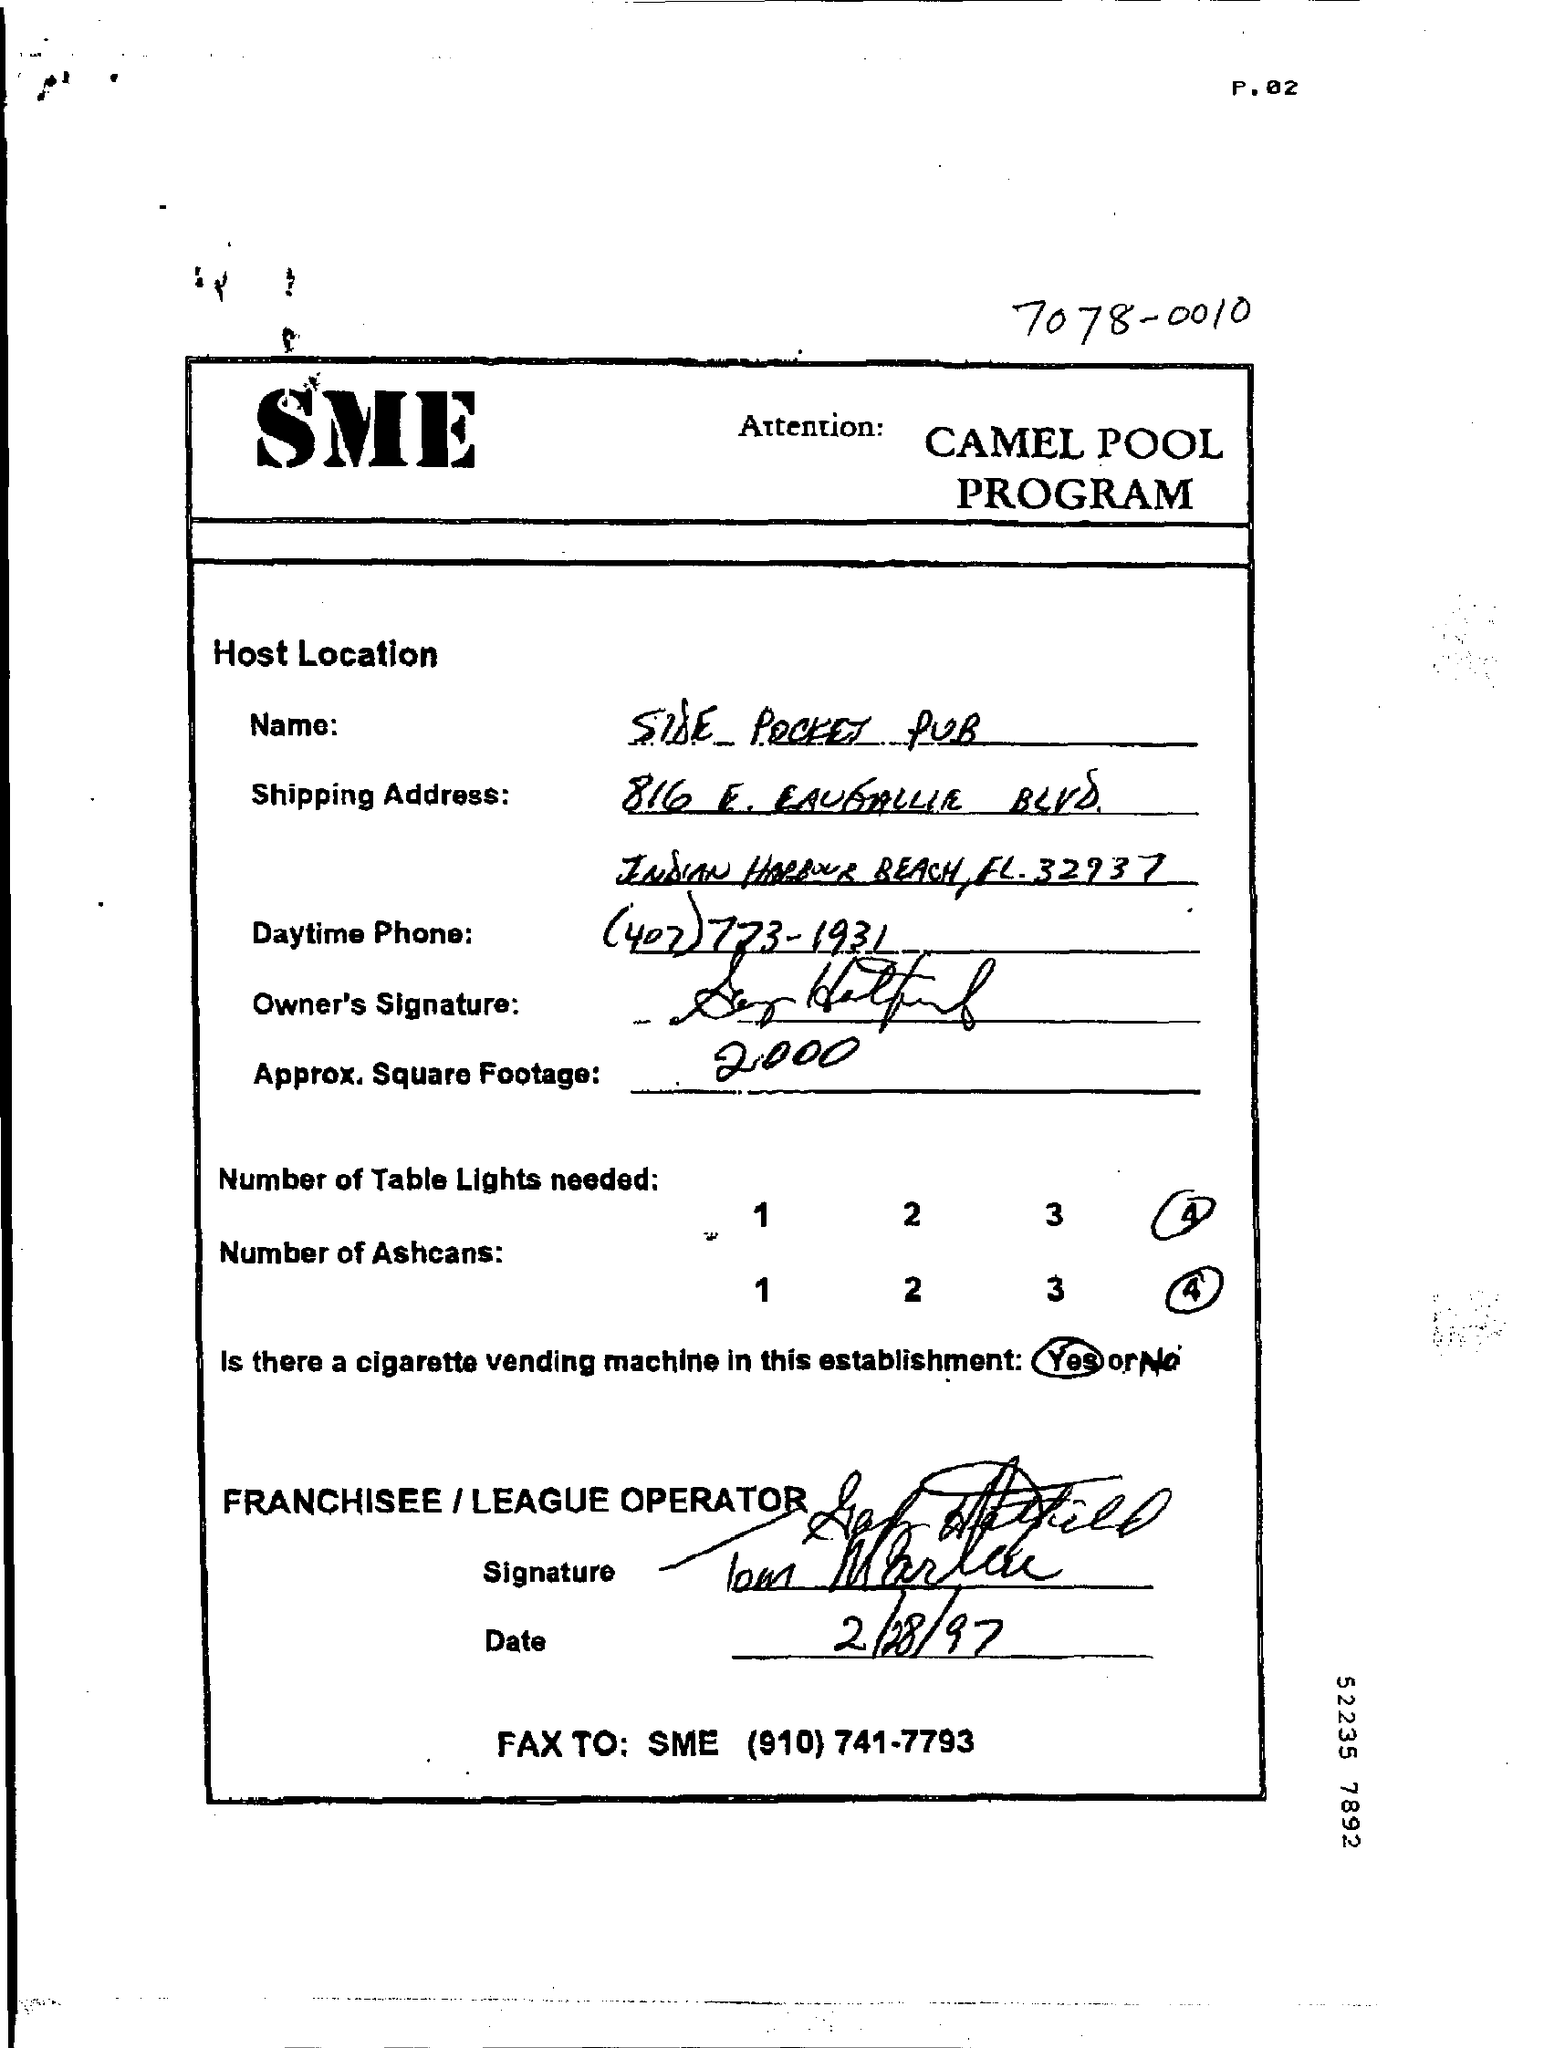Outline some significant characteristics in this image. What are the numbers of Table Lights needed? Four (4). The number of Ashcans needed is 4. The date mentioned is February 28, 1997. The capitalized letters at the top are 'SME'. 